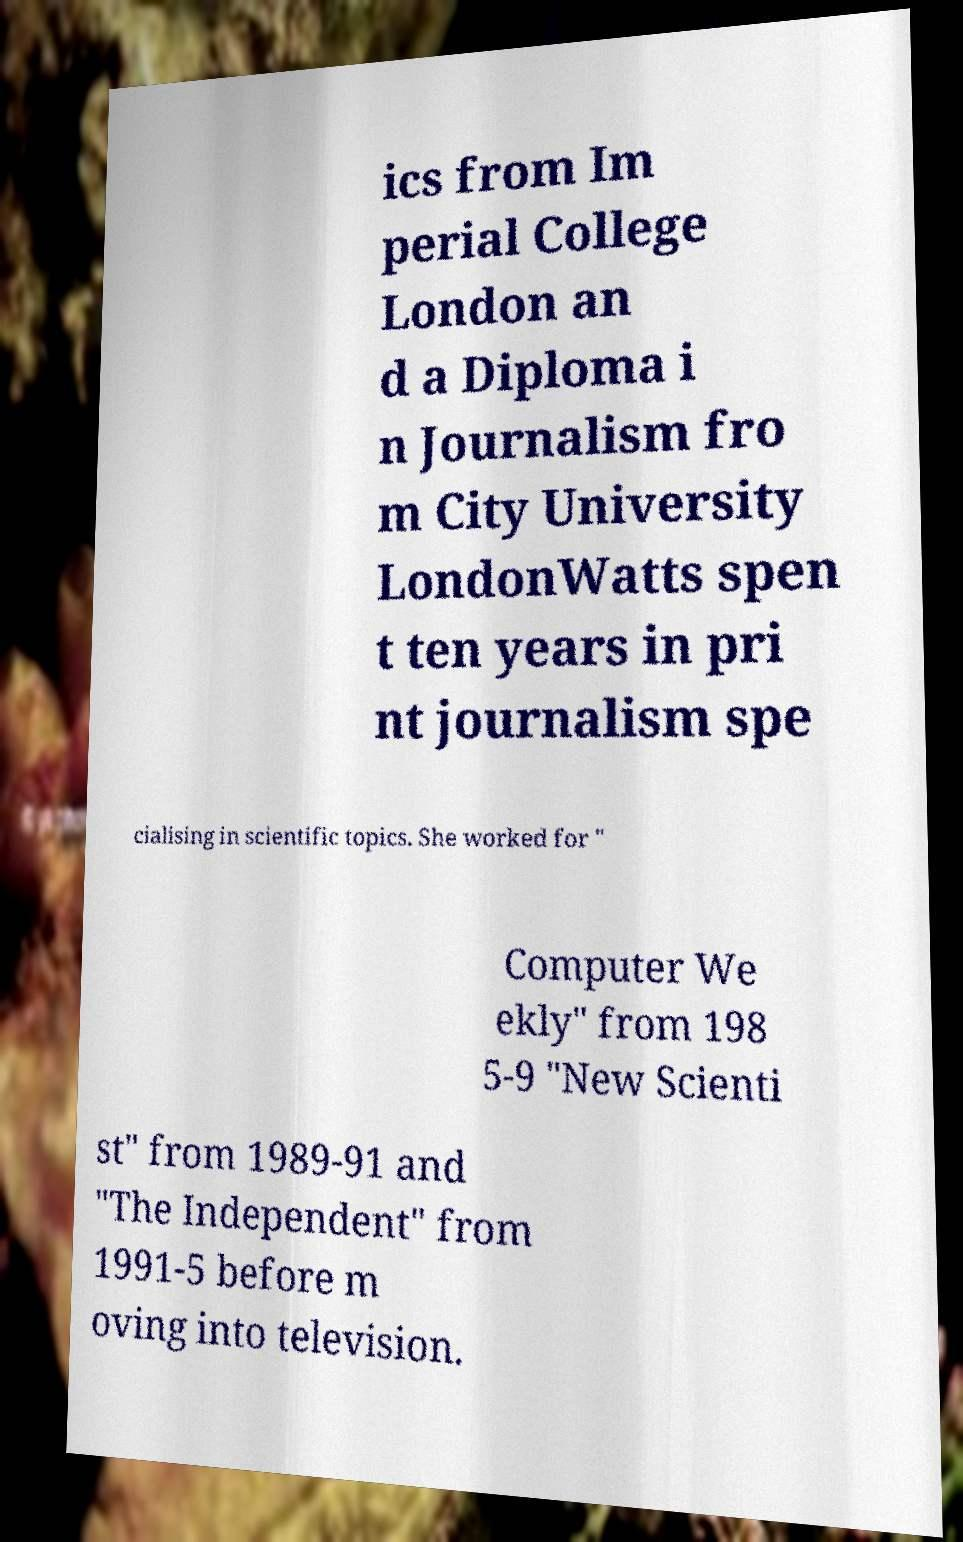Please read and relay the text visible in this image. What does it say? ics from Im perial College London an d a Diploma i n Journalism fro m City University LondonWatts spen t ten years in pri nt journalism spe cialising in scientific topics. She worked for " Computer We ekly" from 198 5-9 "New Scienti st" from 1989-91 and "The Independent" from 1991-5 before m oving into television. 